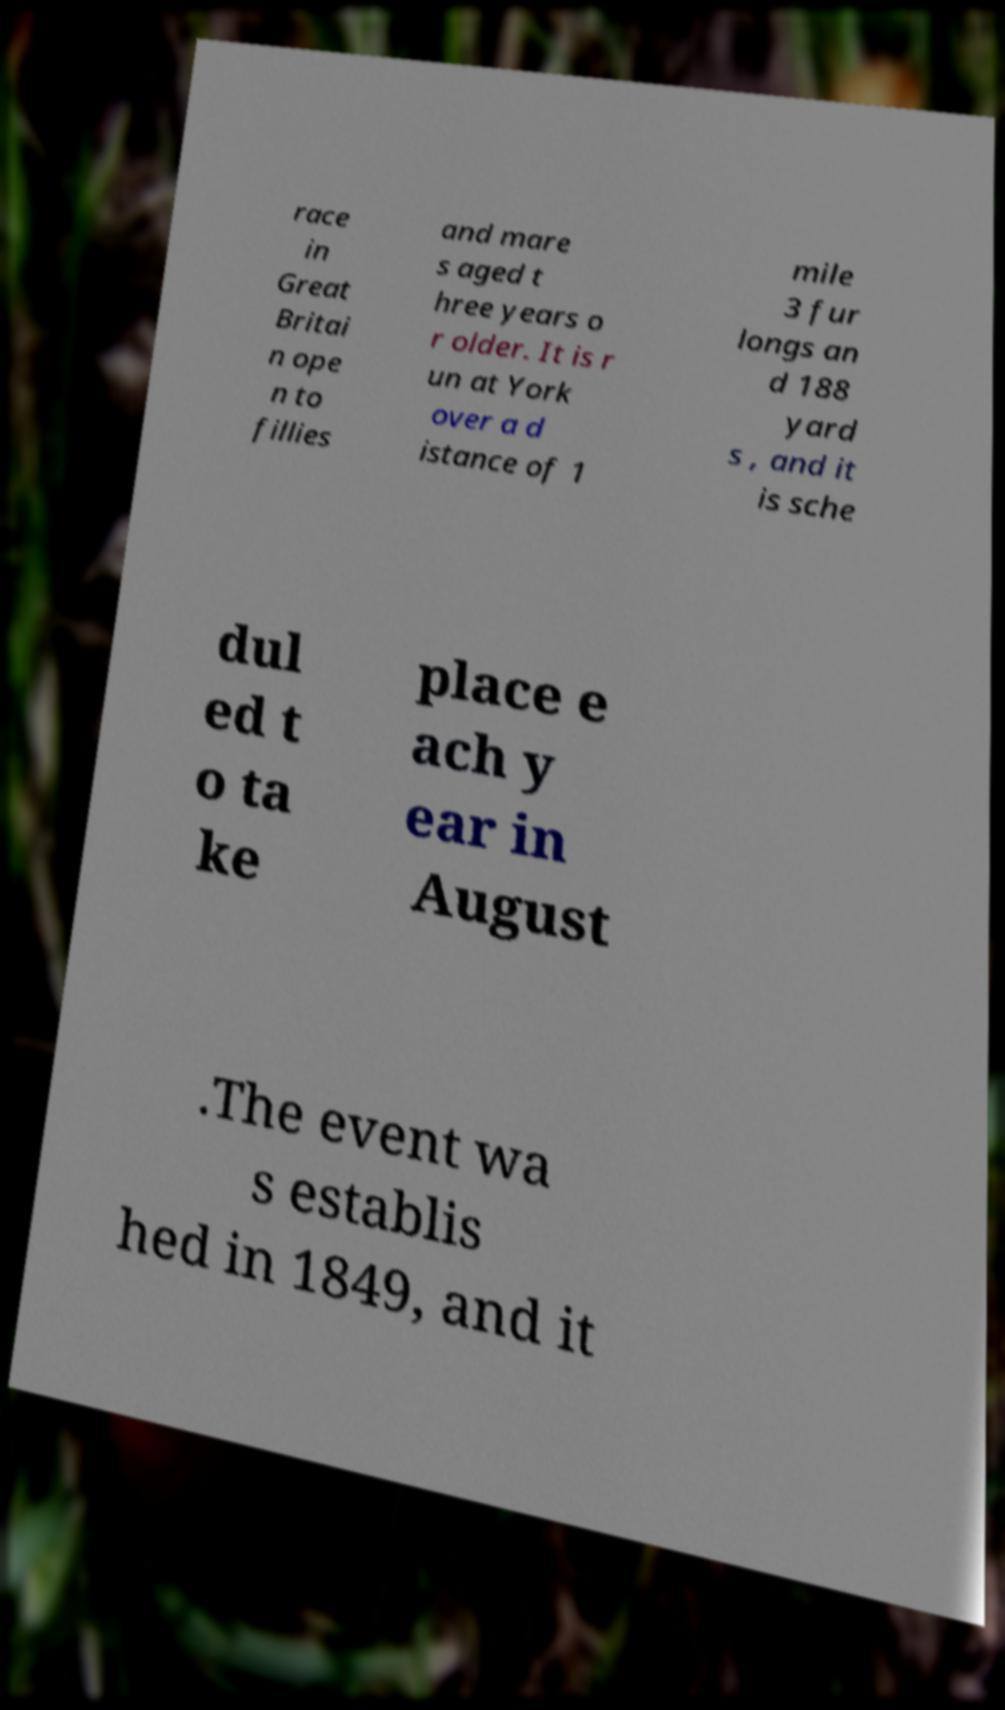Please read and relay the text visible in this image. What does it say? race in Great Britai n ope n to fillies and mare s aged t hree years o r older. It is r un at York over a d istance of 1 mile 3 fur longs an d 188 yard s , and it is sche dul ed t o ta ke place e ach y ear in August .The event wa s establis hed in 1849, and it 